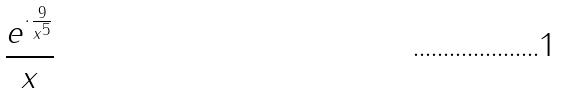<formula> <loc_0><loc_0><loc_500><loc_500>\frac { e ^ { \cdot \frac { 9 } { x ^ { 5 } } } } { x }</formula> 